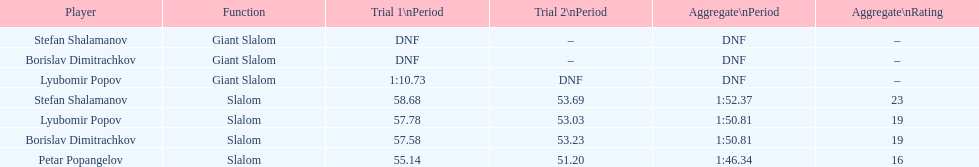Which athlete had a race time above 1:00? Lyubomir Popov. 